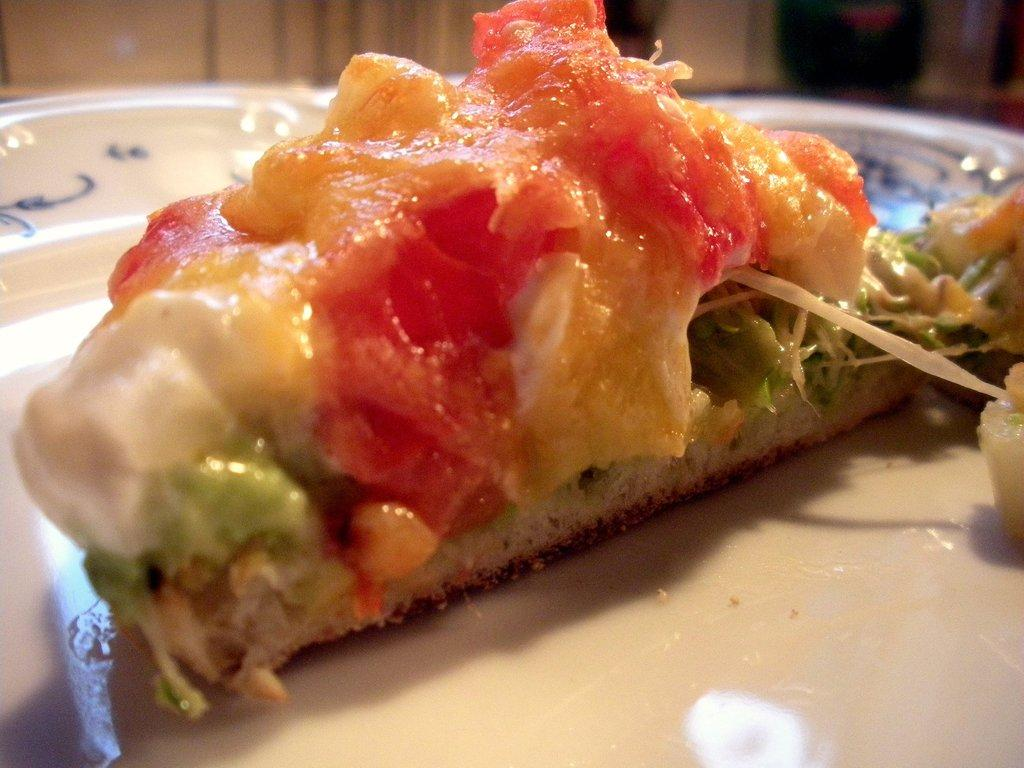What is present in the image related to food? There is food in the image. How is the food arranged or displayed in the image? The food is in a plate. What type of shoes can be seen in the image? There are no shoes present in the image; it only features food in a plate. Can you tell me which direction the ear is facing in the image? There is no ear present in the image; it only features food in a plate. 